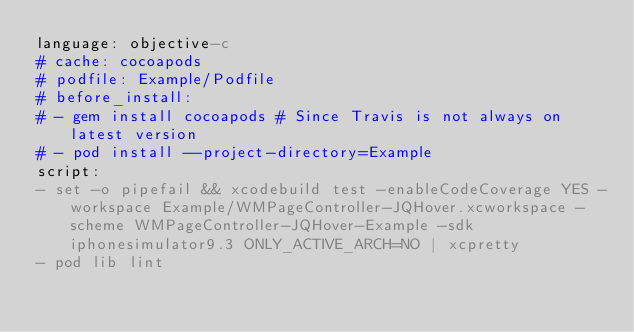Convert code to text. <code><loc_0><loc_0><loc_500><loc_500><_YAML_>language: objective-c
# cache: cocoapods
# podfile: Example/Podfile
# before_install:
# - gem install cocoapods # Since Travis is not always on latest version
# - pod install --project-directory=Example
script:
- set -o pipefail && xcodebuild test -enableCodeCoverage YES -workspace Example/WMPageController-JQHover.xcworkspace -scheme WMPageController-JQHover-Example -sdk iphonesimulator9.3 ONLY_ACTIVE_ARCH=NO | xcpretty
- pod lib lint
</code> 